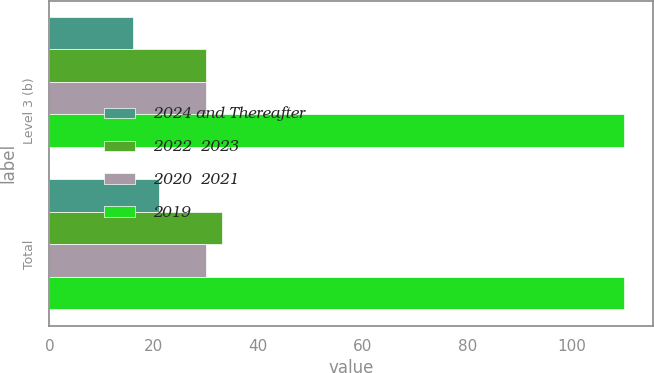<chart> <loc_0><loc_0><loc_500><loc_500><stacked_bar_chart><ecel><fcel>Level 3 (b)<fcel>Total<nl><fcel>2024 and Thereafter<fcel>16<fcel>21<nl><fcel>2022  2023<fcel>30<fcel>33<nl><fcel>2020  2021<fcel>30<fcel>30<nl><fcel>2019<fcel>110<fcel>110<nl></chart> 